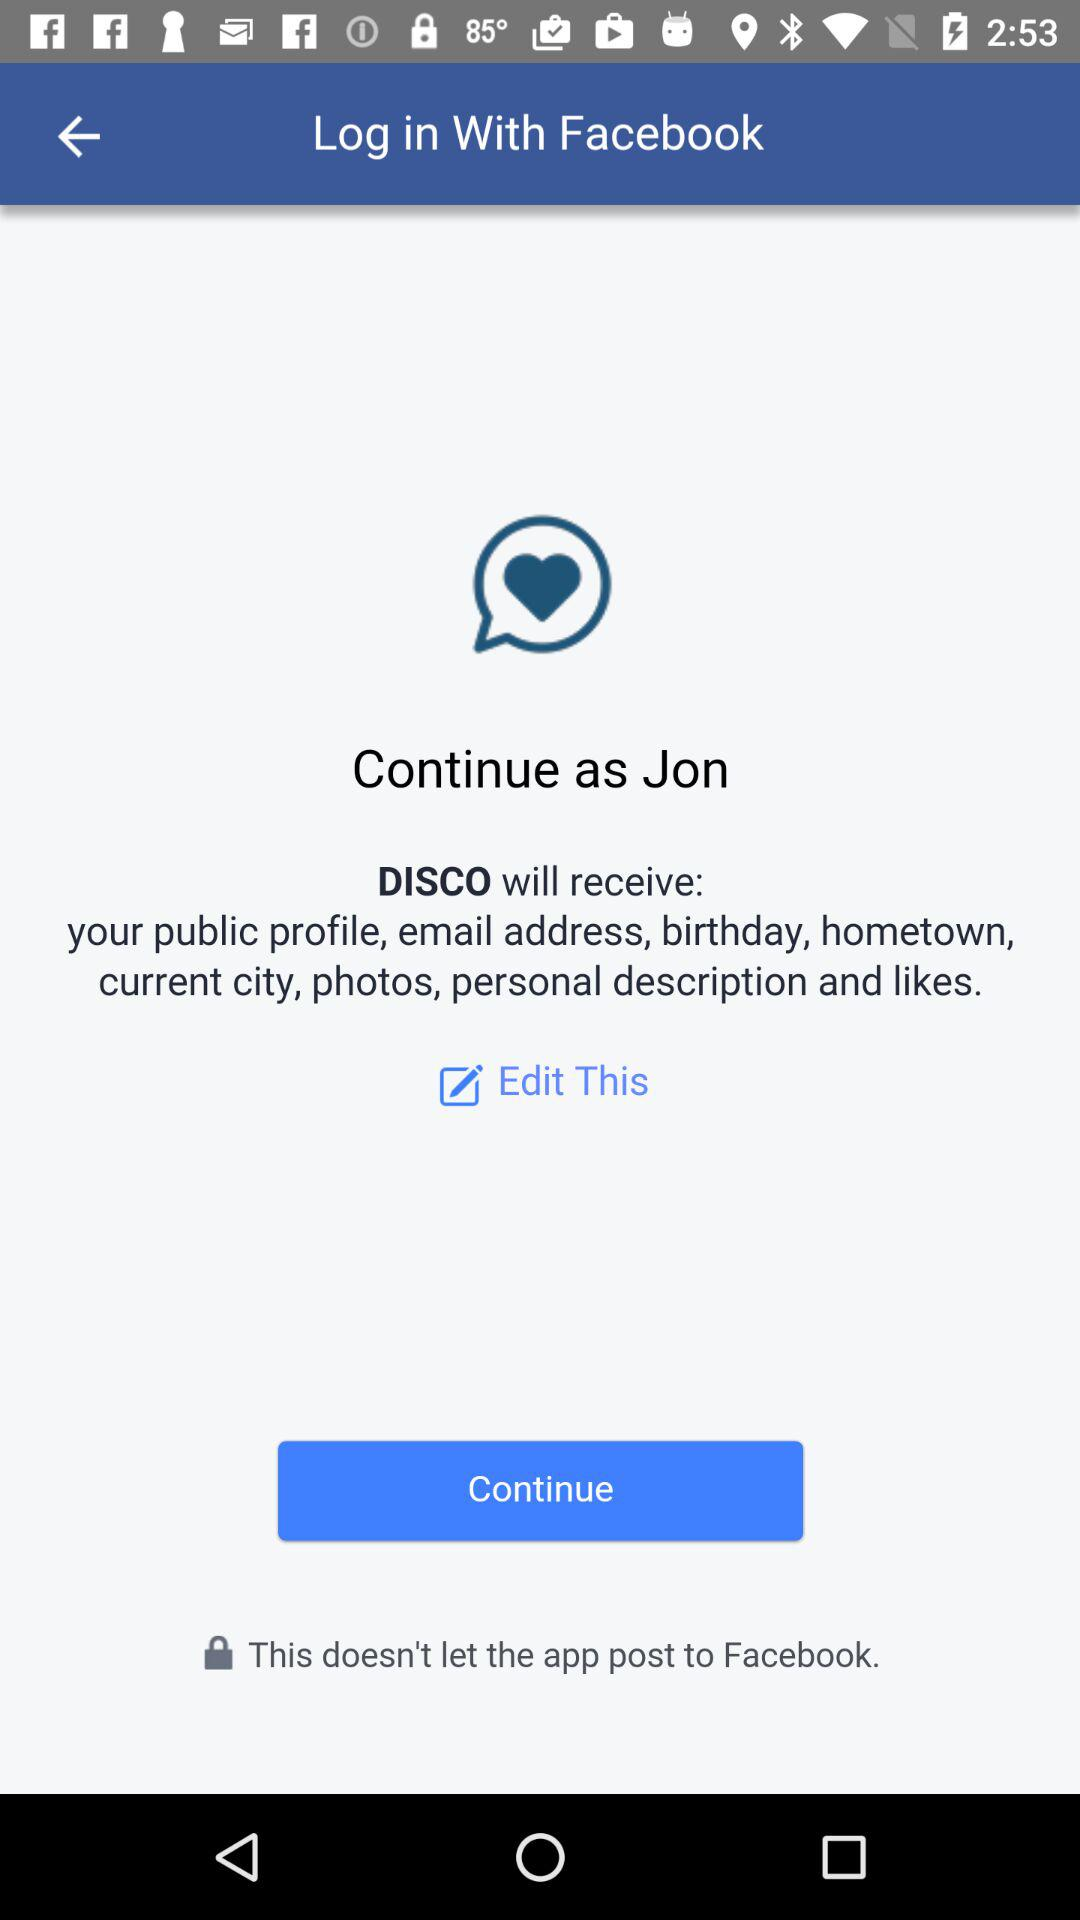How can we log in? You can log in with "Facebook". 